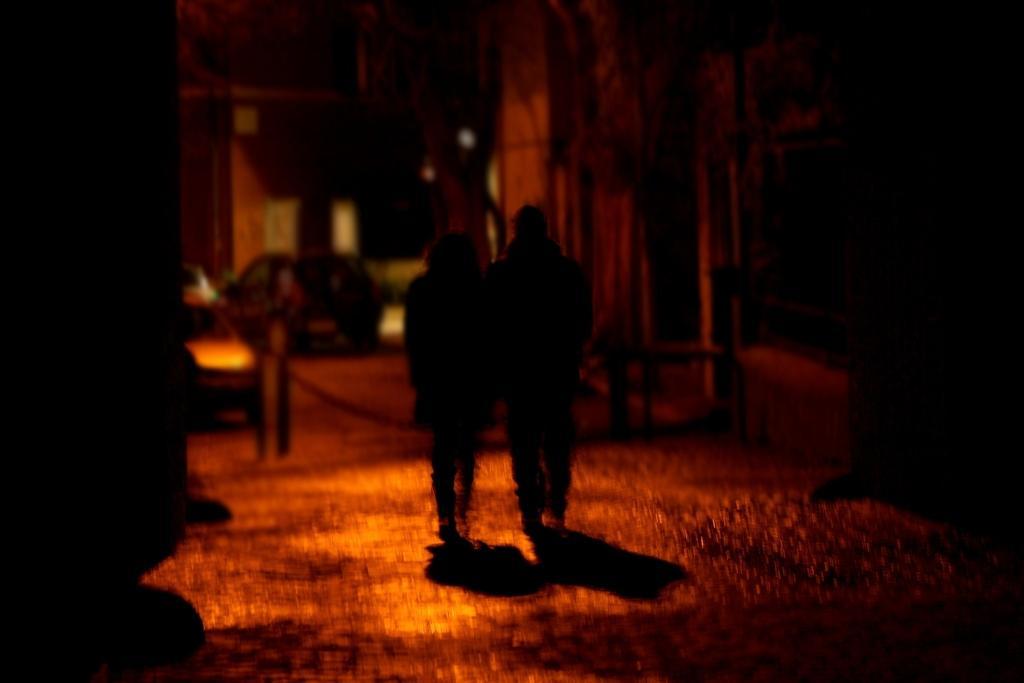Describe this image in one or two sentences. In this image in the center there are persons walking and in the background there are cars, there are buildings. 